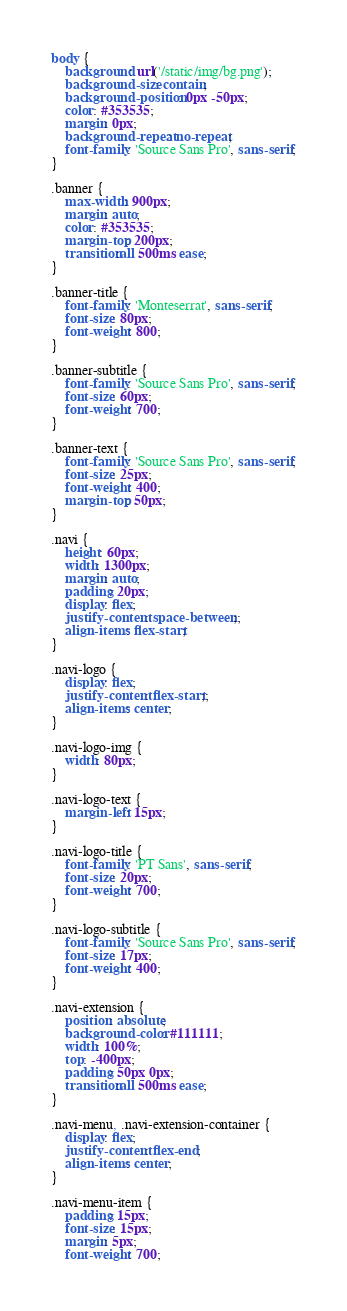<code> <loc_0><loc_0><loc_500><loc_500><_CSS_>body {
    background: url('/static/img/bg.png');
    background-size: contain;
    background-position: 0px -50px;
    color: #353535;
    margin: 0px;
    background-repeat: no-repeat;
    font-family: 'Source Sans Pro', sans-serif;
}

.banner {
    max-width: 900px;
    margin: auto;
    color: #353535;
    margin-top: 200px;
    transition:all 500ms ease;
}

.banner-title {
    font-family: 'Monteserrat', sans-serif;
    font-size: 80px;
    font-weight: 800;
}

.banner-subtitle {
    font-family: 'Source Sans Pro', sans-serif;
    font-size: 60px;
    font-weight: 700;
}

.banner-text {
    font-family: 'Source Sans Pro', sans-serif;
    font-size: 25px;
    font-weight: 400;
    margin-top: 50px;
}

.navi {
    height: 60px;
    width: 1300px;
    margin: auto;
    padding: 20px;
    display: flex;
    justify-content: space-between;;
    align-items: flex-start;
}

.navi-logo {
    display: flex;
    justify-content: flex-start;;
    align-items: center;
}

.navi-logo-img {
    width: 80px;
}

.navi-logo-text {
    margin-left: 15px;
}

.navi-logo-title {
    font-family: 'PT Sans', sans-serif;
    font-size: 20px;
    font-weight: 700;
}

.navi-logo-subtitle {
    font-family: 'Source Sans Pro', sans-serif;
    font-size: 17px;
    font-weight: 400;
}

.navi-extension {
    position: absolute;
    background-color: #111111;
    width: 100%;
    top: -400px;
    padding: 50px 0px;
    transition:all 500ms ease;
}

.navi-menu, .navi-extension-container {
    display: flex;
    justify-content: flex-end;
    align-items: center;
}

.navi-menu-item {
    padding: 15px;
    font-size: 15px;
    margin: 5px;
    font-weight: 700;</code> 